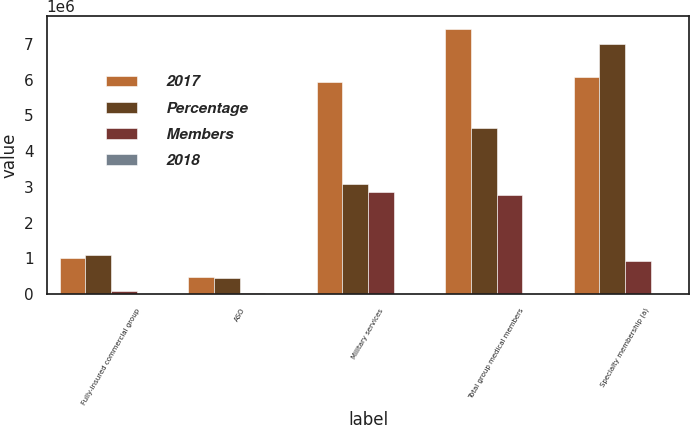Convert chart. <chart><loc_0><loc_0><loc_500><loc_500><stacked_bar_chart><ecel><fcel>Fully-insured commercial group<fcel>ASO<fcel>Military services<fcel>Total group medical members<fcel>Specialty membership (a)<nl><fcel>2017<fcel>1.0047e+06<fcel>481900<fcel>5.9286e+06<fcel>7.4152e+06<fcel>6.0723e+06<nl><fcel>Percentage<fcel>1.0977e+06<fcel>458700<fcel>3.0818e+06<fcel>4.6382e+06<fcel>6.986e+06<nl><fcel>Members<fcel>93000<fcel>23200<fcel>2.8468e+06<fcel>2.777e+06<fcel>913700<nl><fcel>2018<fcel>8.5<fcel>5.1<fcel>92.4<fcel>59.9<fcel>13.1<nl></chart> 